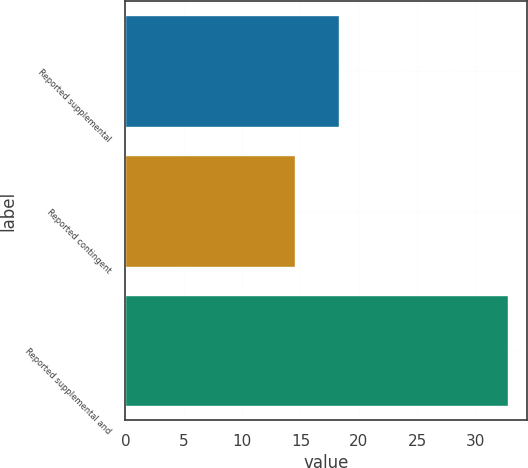Convert chart to OTSL. <chart><loc_0><loc_0><loc_500><loc_500><bar_chart><fcel>Reported supplemental<fcel>Reported contingent<fcel>Reported supplemental and<nl><fcel>18.3<fcel>14.5<fcel>32.8<nl></chart> 